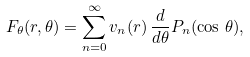<formula> <loc_0><loc_0><loc_500><loc_500>F _ { \theta } ( r , \theta ) = \sum _ { n = 0 } ^ { \infty } v _ { n } ( r ) \, \frac { d } { d \theta } P _ { n } ( \cos \, \theta ) ,</formula> 